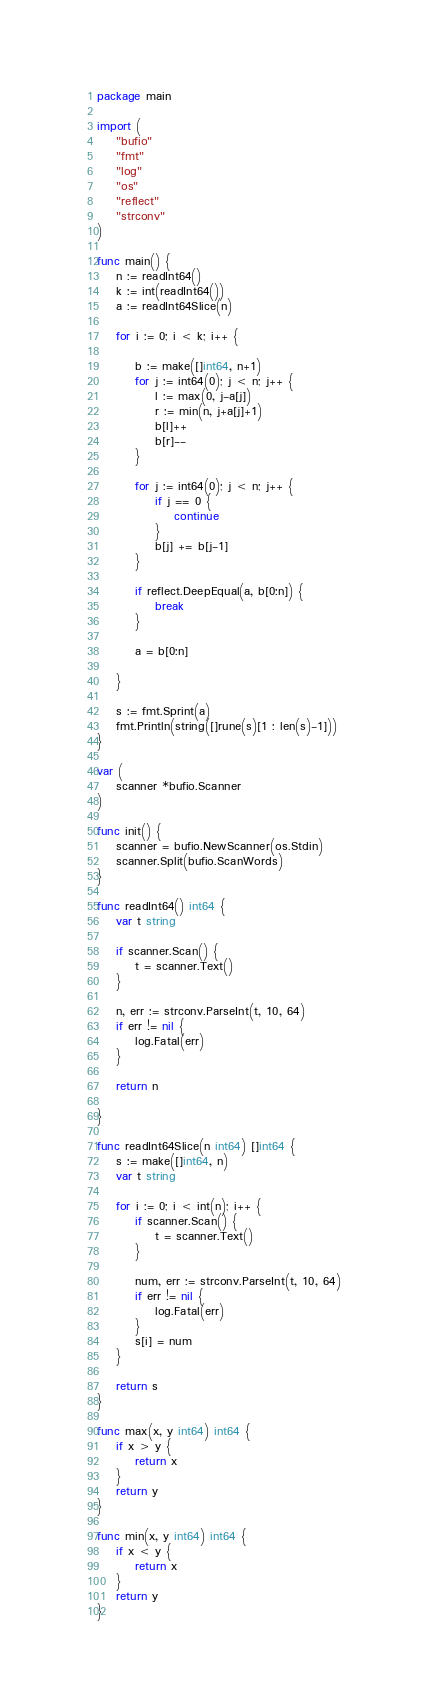<code> <loc_0><loc_0><loc_500><loc_500><_Go_>package main

import (
	"bufio"
	"fmt"
	"log"
	"os"
	"reflect"
	"strconv"
)

func main() {
	n := readInt64()
	k := int(readInt64())
	a := readInt64Slice(n)

	for i := 0; i < k; i++ {

		b := make([]int64, n+1)
		for j := int64(0); j < n; j++ {
			l := max(0, j-a[j])
			r := min(n, j+a[j]+1)
			b[l]++
			b[r]--
		}

		for j := int64(0); j < n; j++ {
			if j == 0 {
				continue
			}
			b[j] += b[j-1]
		}

		if reflect.DeepEqual(a, b[0:n]) {
			break
		}

		a = b[0:n]

	}

	s := fmt.Sprint(a)
	fmt.Println(string([]rune(s)[1 : len(s)-1]))
}

var (
	scanner *bufio.Scanner
)

func init() {
	scanner = bufio.NewScanner(os.Stdin)
	scanner.Split(bufio.ScanWords)
}

func readInt64() int64 {
	var t string

	if scanner.Scan() {
		t = scanner.Text()
	}

	n, err := strconv.ParseInt(t, 10, 64)
	if err != nil {
		log.Fatal(err)
	}

	return n

}

func readInt64Slice(n int64) []int64 {
	s := make([]int64, n)
	var t string

	for i := 0; i < int(n); i++ {
		if scanner.Scan() {
			t = scanner.Text()
		}

		num, err := strconv.ParseInt(t, 10, 64)
		if err != nil {
			log.Fatal(err)
		}
		s[i] = num
	}

	return s
}

func max(x, y int64) int64 {
	if x > y {
		return x
	}
	return y
}

func min(x, y int64) int64 {
	if x < y {
		return x
	}
	return y
}
</code> 